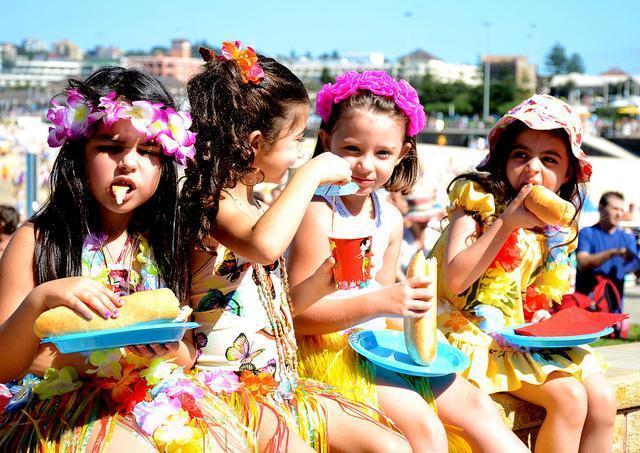How many children are here?
Give a very brief answer. 4. How many hot dogs can you see?
Give a very brief answer. 2. How many people are visible?
Give a very brief answer. 5. 